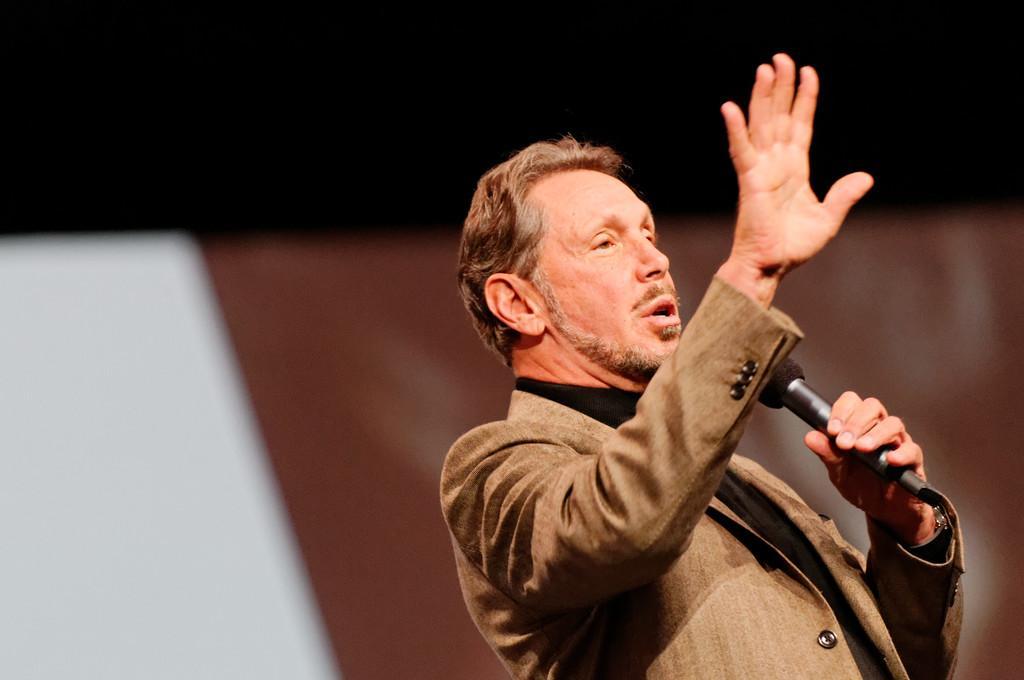How would you summarize this image in a sentence or two? man standing, holding mike,wearing watch, in the background there is brown color sheet in the left there is white color sheet. 